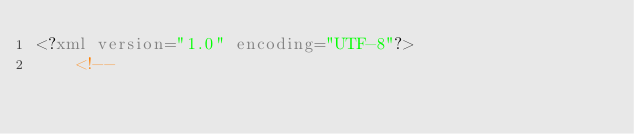<code> <loc_0><loc_0><loc_500><loc_500><_XML_><?xml version="1.0" encoding="UTF-8"?>
	<!--</code> 